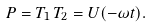<formula> <loc_0><loc_0><loc_500><loc_500>P = T _ { 1 } \, T _ { 2 } = U ( - \omega t ) .</formula> 